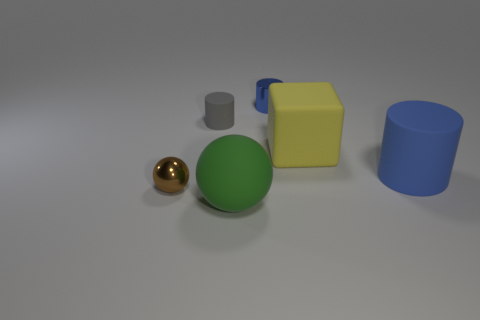Add 1 large yellow rubber cubes. How many objects exist? 7 Subtract all spheres. How many objects are left? 4 Add 3 big blue objects. How many big blue objects are left? 4 Add 5 gray rubber cylinders. How many gray rubber cylinders exist? 6 Subtract 0 blue spheres. How many objects are left? 6 Subtract all tiny brown things. Subtract all tiny cyan spheres. How many objects are left? 5 